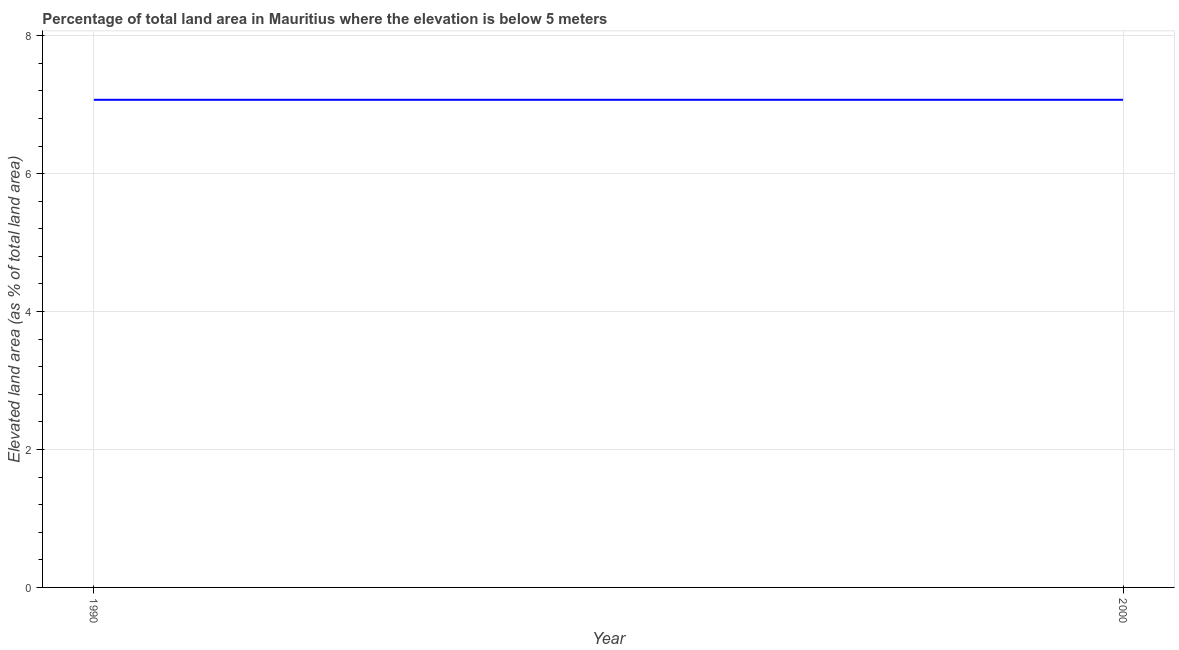What is the total elevated land area in 2000?
Your answer should be compact. 7.07. Across all years, what is the maximum total elevated land area?
Your answer should be compact. 7.07. Across all years, what is the minimum total elevated land area?
Keep it short and to the point. 7.07. In which year was the total elevated land area minimum?
Your response must be concise. 1990. What is the sum of the total elevated land area?
Ensure brevity in your answer.  14.14. What is the average total elevated land area per year?
Provide a succinct answer. 7.07. What is the median total elevated land area?
Give a very brief answer. 7.07. Does the total elevated land area monotonically increase over the years?
Your response must be concise. No. How many lines are there?
Give a very brief answer. 1. Does the graph contain grids?
Provide a succinct answer. Yes. What is the title of the graph?
Keep it short and to the point. Percentage of total land area in Mauritius where the elevation is below 5 meters. What is the label or title of the X-axis?
Provide a succinct answer. Year. What is the label or title of the Y-axis?
Your answer should be compact. Elevated land area (as % of total land area). What is the Elevated land area (as % of total land area) in 1990?
Your answer should be very brief. 7.07. What is the Elevated land area (as % of total land area) of 2000?
Offer a terse response. 7.07. What is the ratio of the Elevated land area (as % of total land area) in 1990 to that in 2000?
Your answer should be very brief. 1. 